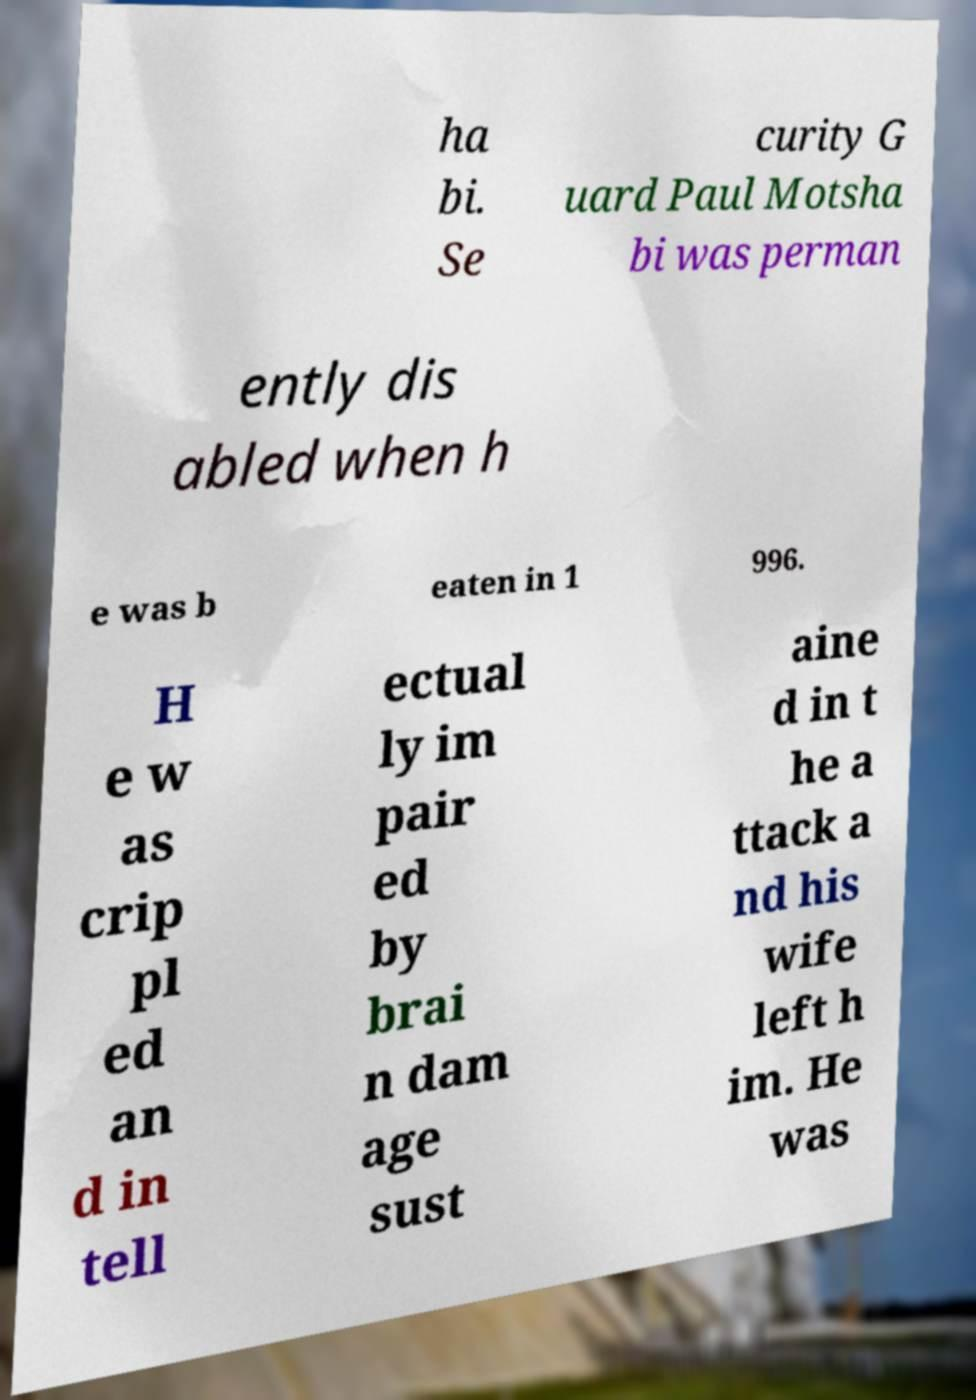Please identify and transcribe the text found in this image. ha bi. Se curity G uard Paul Motsha bi was perman ently dis abled when h e was b eaten in 1 996. H e w as crip pl ed an d in tell ectual ly im pair ed by brai n dam age sust aine d in t he a ttack a nd his wife left h im. He was 